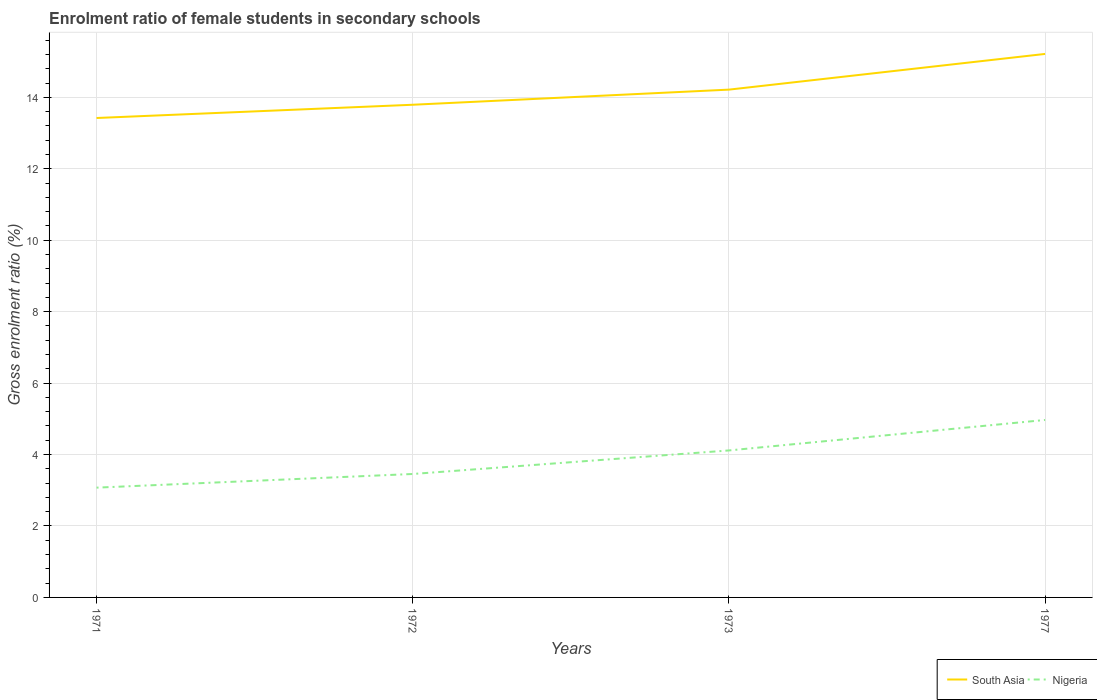Does the line corresponding to Nigeria intersect with the line corresponding to South Asia?
Your answer should be compact. No. Across all years, what is the maximum enrolment ratio of female students in secondary schools in South Asia?
Provide a succinct answer. 13.42. What is the total enrolment ratio of female students in secondary schools in Nigeria in the graph?
Provide a short and direct response. -0.38. What is the difference between the highest and the second highest enrolment ratio of female students in secondary schools in South Asia?
Offer a very short reply. 1.79. Is the enrolment ratio of female students in secondary schools in South Asia strictly greater than the enrolment ratio of female students in secondary schools in Nigeria over the years?
Ensure brevity in your answer.  No. How many lines are there?
Provide a short and direct response. 2. Are the values on the major ticks of Y-axis written in scientific E-notation?
Keep it short and to the point. No. Does the graph contain grids?
Your answer should be compact. Yes. How many legend labels are there?
Your answer should be compact. 2. How are the legend labels stacked?
Your answer should be very brief. Horizontal. What is the title of the graph?
Provide a succinct answer. Enrolment ratio of female students in secondary schools. What is the label or title of the X-axis?
Keep it short and to the point. Years. What is the Gross enrolment ratio (%) of South Asia in 1971?
Offer a terse response. 13.42. What is the Gross enrolment ratio (%) in Nigeria in 1971?
Ensure brevity in your answer.  3.07. What is the Gross enrolment ratio (%) of South Asia in 1972?
Ensure brevity in your answer.  13.79. What is the Gross enrolment ratio (%) in Nigeria in 1972?
Offer a very short reply. 3.46. What is the Gross enrolment ratio (%) in South Asia in 1973?
Keep it short and to the point. 14.22. What is the Gross enrolment ratio (%) in Nigeria in 1973?
Provide a succinct answer. 4.12. What is the Gross enrolment ratio (%) of South Asia in 1977?
Your answer should be very brief. 15.22. What is the Gross enrolment ratio (%) of Nigeria in 1977?
Give a very brief answer. 4.97. Across all years, what is the maximum Gross enrolment ratio (%) of South Asia?
Keep it short and to the point. 15.22. Across all years, what is the maximum Gross enrolment ratio (%) in Nigeria?
Provide a succinct answer. 4.97. Across all years, what is the minimum Gross enrolment ratio (%) in South Asia?
Your response must be concise. 13.42. Across all years, what is the minimum Gross enrolment ratio (%) of Nigeria?
Give a very brief answer. 3.07. What is the total Gross enrolment ratio (%) in South Asia in the graph?
Make the answer very short. 56.65. What is the total Gross enrolment ratio (%) of Nigeria in the graph?
Make the answer very short. 15.61. What is the difference between the Gross enrolment ratio (%) of South Asia in 1971 and that in 1972?
Offer a terse response. -0.37. What is the difference between the Gross enrolment ratio (%) of Nigeria in 1971 and that in 1972?
Offer a terse response. -0.38. What is the difference between the Gross enrolment ratio (%) in South Asia in 1971 and that in 1973?
Your answer should be very brief. -0.79. What is the difference between the Gross enrolment ratio (%) in Nigeria in 1971 and that in 1973?
Your answer should be compact. -1.04. What is the difference between the Gross enrolment ratio (%) in South Asia in 1971 and that in 1977?
Offer a very short reply. -1.79. What is the difference between the Gross enrolment ratio (%) in Nigeria in 1971 and that in 1977?
Make the answer very short. -1.89. What is the difference between the Gross enrolment ratio (%) of South Asia in 1972 and that in 1973?
Your answer should be very brief. -0.42. What is the difference between the Gross enrolment ratio (%) in Nigeria in 1972 and that in 1973?
Offer a very short reply. -0.66. What is the difference between the Gross enrolment ratio (%) in South Asia in 1972 and that in 1977?
Your response must be concise. -1.42. What is the difference between the Gross enrolment ratio (%) of Nigeria in 1972 and that in 1977?
Keep it short and to the point. -1.51. What is the difference between the Gross enrolment ratio (%) of South Asia in 1973 and that in 1977?
Keep it short and to the point. -1. What is the difference between the Gross enrolment ratio (%) of Nigeria in 1973 and that in 1977?
Your answer should be very brief. -0.85. What is the difference between the Gross enrolment ratio (%) in South Asia in 1971 and the Gross enrolment ratio (%) in Nigeria in 1972?
Ensure brevity in your answer.  9.97. What is the difference between the Gross enrolment ratio (%) of South Asia in 1971 and the Gross enrolment ratio (%) of Nigeria in 1973?
Your response must be concise. 9.31. What is the difference between the Gross enrolment ratio (%) in South Asia in 1971 and the Gross enrolment ratio (%) in Nigeria in 1977?
Your answer should be compact. 8.45. What is the difference between the Gross enrolment ratio (%) in South Asia in 1972 and the Gross enrolment ratio (%) in Nigeria in 1973?
Your answer should be compact. 9.68. What is the difference between the Gross enrolment ratio (%) in South Asia in 1972 and the Gross enrolment ratio (%) in Nigeria in 1977?
Offer a very short reply. 8.83. What is the difference between the Gross enrolment ratio (%) in South Asia in 1973 and the Gross enrolment ratio (%) in Nigeria in 1977?
Provide a short and direct response. 9.25. What is the average Gross enrolment ratio (%) of South Asia per year?
Offer a very short reply. 14.16. What is the average Gross enrolment ratio (%) of Nigeria per year?
Offer a very short reply. 3.9. In the year 1971, what is the difference between the Gross enrolment ratio (%) in South Asia and Gross enrolment ratio (%) in Nigeria?
Provide a succinct answer. 10.35. In the year 1972, what is the difference between the Gross enrolment ratio (%) of South Asia and Gross enrolment ratio (%) of Nigeria?
Your response must be concise. 10.34. In the year 1973, what is the difference between the Gross enrolment ratio (%) in South Asia and Gross enrolment ratio (%) in Nigeria?
Provide a succinct answer. 10.1. In the year 1977, what is the difference between the Gross enrolment ratio (%) in South Asia and Gross enrolment ratio (%) in Nigeria?
Your answer should be very brief. 10.25. What is the ratio of the Gross enrolment ratio (%) in South Asia in 1971 to that in 1972?
Offer a terse response. 0.97. What is the ratio of the Gross enrolment ratio (%) in Nigeria in 1971 to that in 1972?
Keep it short and to the point. 0.89. What is the ratio of the Gross enrolment ratio (%) in South Asia in 1971 to that in 1973?
Your response must be concise. 0.94. What is the ratio of the Gross enrolment ratio (%) in Nigeria in 1971 to that in 1973?
Keep it short and to the point. 0.75. What is the ratio of the Gross enrolment ratio (%) in South Asia in 1971 to that in 1977?
Make the answer very short. 0.88. What is the ratio of the Gross enrolment ratio (%) of Nigeria in 1971 to that in 1977?
Provide a succinct answer. 0.62. What is the ratio of the Gross enrolment ratio (%) of South Asia in 1972 to that in 1973?
Your answer should be compact. 0.97. What is the ratio of the Gross enrolment ratio (%) of Nigeria in 1972 to that in 1973?
Offer a terse response. 0.84. What is the ratio of the Gross enrolment ratio (%) in South Asia in 1972 to that in 1977?
Your response must be concise. 0.91. What is the ratio of the Gross enrolment ratio (%) of Nigeria in 1972 to that in 1977?
Your answer should be compact. 0.7. What is the ratio of the Gross enrolment ratio (%) of South Asia in 1973 to that in 1977?
Your response must be concise. 0.93. What is the ratio of the Gross enrolment ratio (%) in Nigeria in 1973 to that in 1977?
Give a very brief answer. 0.83. What is the difference between the highest and the second highest Gross enrolment ratio (%) in South Asia?
Keep it short and to the point. 1. What is the difference between the highest and the second highest Gross enrolment ratio (%) in Nigeria?
Your response must be concise. 0.85. What is the difference between the highest and the lowest Gross enrolment ratio (%) of South Asia?
Offer a very short reply. 1.79. What is the difference between the highest and the lowest Gross enrolment ratio (%) in Nigeria?
Your answer should be compact. 1.89. 